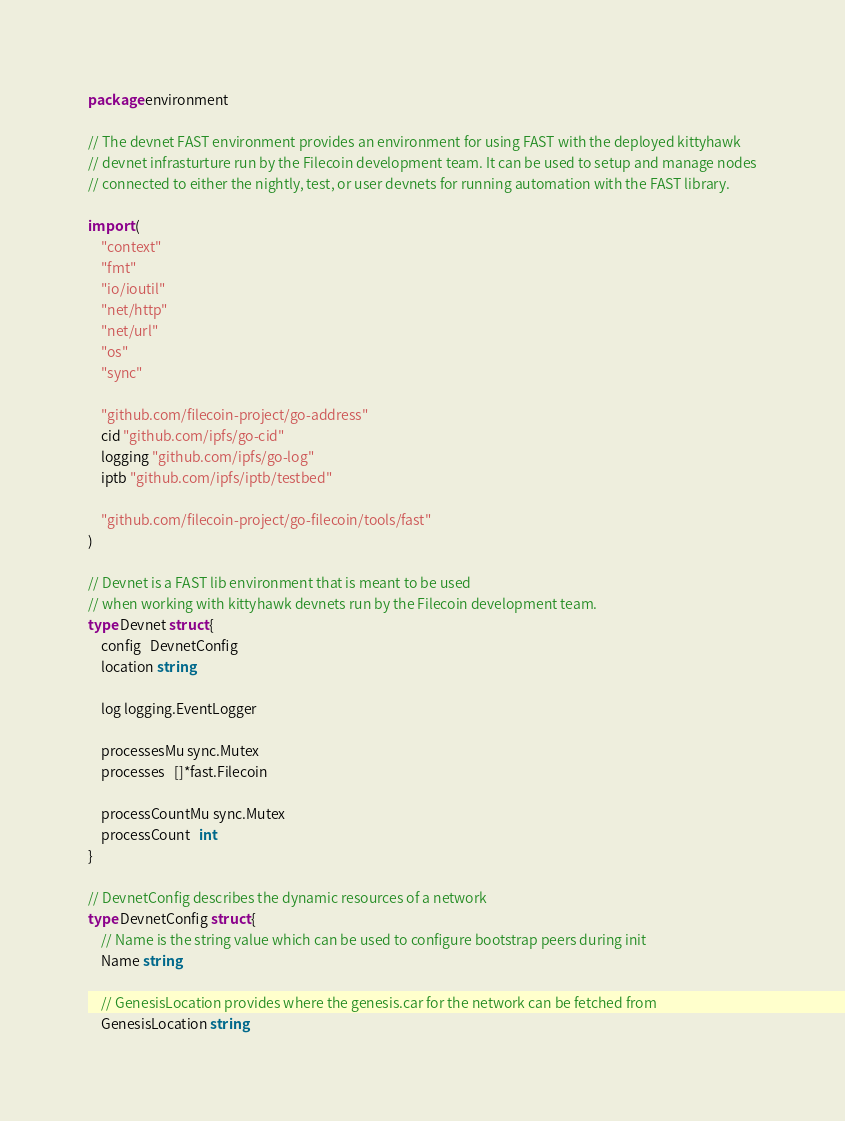Convert code to text. <code><loc_0><loc_0><loc_500><loc_500><_Go_>package environment

// The devnet FAST environment provides an environment for using FAST with the deployed kittyhawk
// devnet infrasturture run by the Filecoin development team. It can be used to setup and manage nodes
// connected to either the nightly, test, or user devnets for running automation with the FAST library.

import (
	"context"
	"fmt"
	"io/ioutil"
	"net/http"
	"net/url"
	"os"
	"sync"

	"github.com/filecoin-project/go-address"
	cid "github.com/ipfs/go-cid"
	logging "github.com/ipfs/go-log"
	iptb "github.com/ipfs/iptb/testbed"

	"github.com/filecoin-project/go-filecoin/tools/fast"
)

// Devnet is a FAST lib environment that is meant to be used
// when working with kittyhawk devnets run by the Filecoin development team.
type Devnet struct {
	config   DevnetConfig
	location string

	log logging.EventLogger

	processesMu sync.Mutex
	processes   []*fast.Filecoin

	processCountMu sync.Mutex
	processCount   int
}

// DevnetConfig describes the dynamic resources of a network
type DevnetConfig struct {
	// Name is the string value which can be used to configure bootstrap peers during init
	Name string

	// GenesisLocation provides where the genesis.car for the network can be fetched from
	GenesisLocation string
</code> 